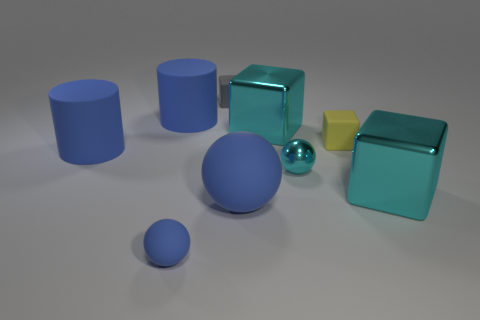There is a blue ball that is right of the tiny gray thing; what size is it?
Offer a terse response. Large. What number of big things are green spheres or matte objects?
Offer a terse response. 3. There is a small thing that is both behind the small blue object and in front of the tiny yellow rubber thing; what is its color?
Make the answer very short. Cyan. Are there any other objects that have the same shape as the yellow matte thing?
Your response must be concise. Yes. What is the cyan ball made of?
Provide a short and direct response. Metal. Are there any big blocks left of the small blue thing?
Make the answer very short. No. Does the small metal thing have the same shape as the tiny blue thing?
Provide a short and direct response. Yes. What number of other objects are there of the same size as the gray matte object?
Offer a very short reply. 3. How many things are either large cyan blocks that are behind the small yellow rubber cube or big balls?
Make the answer very short. 2. The tiny metal sphere has what color?
Your response must be concise. Cyan. 